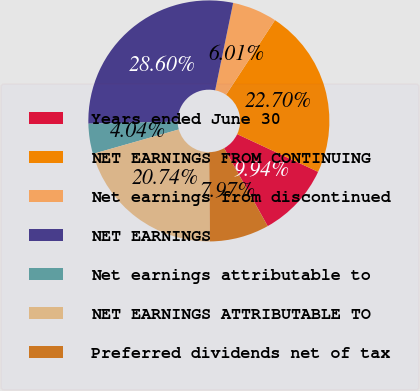<chart> <loc_0><loc_0><loc_500><loc_500><pie_chart><fcel>Years ended June 30<fcel>NET EARNINGS FROM CONTINUING<fcel>Net earnings from discontinued<fcel>NET EARNINGS<fcel>Net earnings attributable to<fcel>NET EARNINGS ATTRIBUTABLE TO<fcel>Preferred dividends net of tax<nl><fcel>9.94%<fcel>22.7%<fcel>6.01%<fcel>28.6%<fcel>4.04%<fcel>20.74%<fcel>7.97%<nl></chart> 